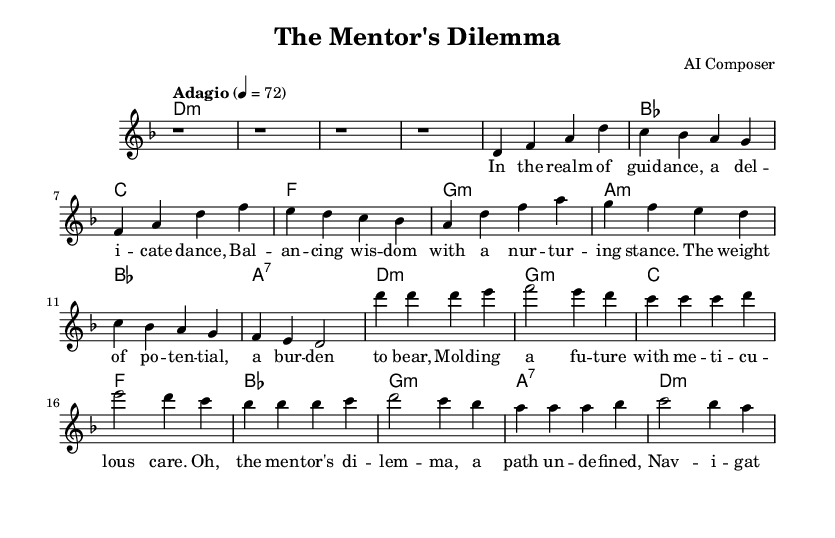What is the key signature of this music? The key signature is indicated by the key signature at the beginning of the staff, which shows one flat. This corresponds to D minor, as it has one flat (B flat).
Answer: D minor What is the time signature of this music? The time signature is located at the beginning of the score after the key signature. It indicates that there are four beats per measure, as shown by the 4/4 notation.
Answer: 4/4 What is the tempo marking for the piece? The tempo marking appears at the beginning of the music and indicates the speed of the piece, which in this case is "Adagio" with a metronome marking of 72 beats per minute.
Answer: Adagio, 72 How many measures are in the introduction? The introduction section has a total of four measures, as indicated by the four rest symbols shown consecutively at the beginning.
Answer: 4 What is the primary theme of the aria reflected in the lyrics? The primary theme can be deduced from the lyrics, which discuss the complexities and challenges of mentorship, particularly the balance between empowerment and sheltering. This reflects the emotional and psychological intricacies attributed to coaching.
Answer: Mentorship complexities Which musical instruments are indicated for this piece? The indicated instrument for this piece is shown in the staff indication where it specifies "choir aahs," which implies vocal performance rather than a traditional instrument.
Answer: Choir aahs What characterizes the harmony used in the chorus? Analyzing the chord progression in the chorus, it primarily shifts between minor and major chords, reflecting both tension and resolution, a common trait in opera reflecting deep emotional contrasts.
Answer: Minor and major chords 